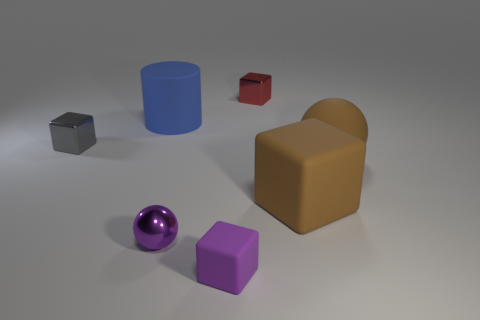There is a metallic cube that is to the right of the matte object behind the shiny object left of the big blue matte object; what is its size? The small, metallic cube situated to the right of the matte brown object and behind the shiny sphere, to the left of the large blue cylinder, is visually smaller compared to the surrounding objects. Its scale is modest relative to the dimensions of the scene. 